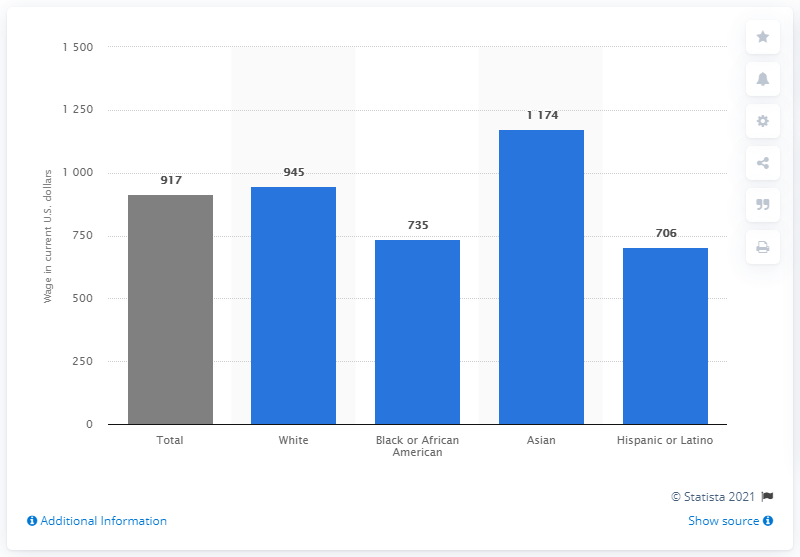Indicate a few pertinent items in this graphic. In 2019, the median weekly earnings of a full-time Hispanic employee in the United States was $706 per week. 